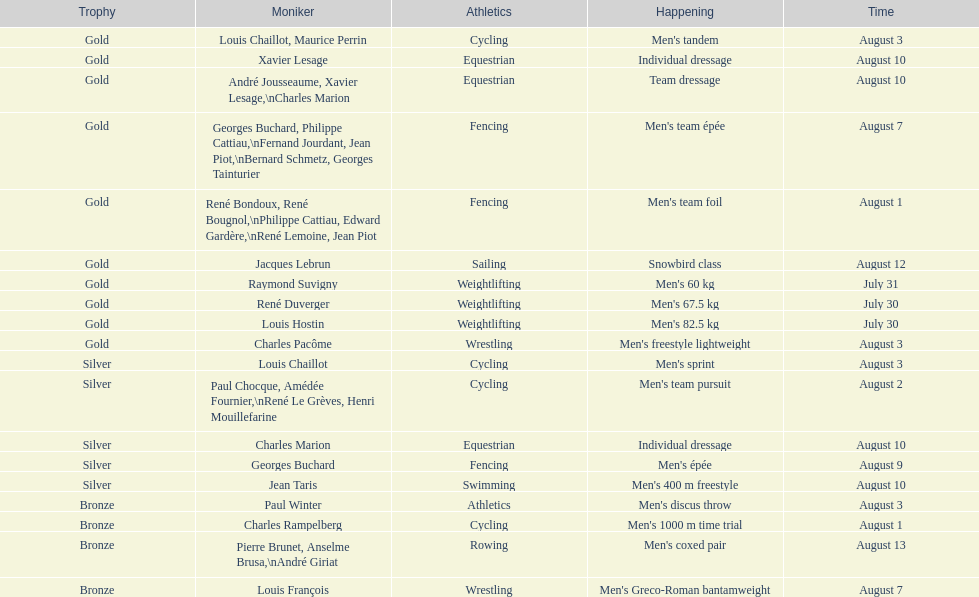I'm looking to parse the entire table for insights. Could you assist me with that? {'header': ['Trophy', 'Moniker', 'Athletics', 'Happening', 'Time'], 'rows': [['Gold', 'Louis Chaillot, Maurice Perrin', 'Cycling', "Men's tandem", 'August 3'], ['Gold', 'Xavier Lesage', 'Equestrian', 'Individual dressage', 'August 10'], ['Gold', 'André Jousseaume, Xavier Lesage,\\nCharles Marion', 'Equestrian', 'Team dressage', 'August 10'], ['Gold', 'Georges Buchard, Philippe Cattiau,\\nFernand Jourdant, Jean Piot,\\nBernard Schmetz, Georges Tainturier', 'Fencing', "Men's team épée", 'August 7'], ['Gold', 'René Bondoux, René Bougnol,\\nPhilippe Cattiau, Edward Gardère,\\nRené Lemoine, Jean Piot', 'Fencing', "Men's team foil", 'August 1'], ['Gold', 'Jacques Lebrun', 'Sailing', 'Snowbird class', 'August 12'], ['Gold', 'Raymond Suvigny', 'Weightlifting', "Men's 60 kg", 'July 31'], ['Gold', 'René Duverger', 'Weightlifting', "Men's 67.5 kg", 'July 30'], ['Gold', 'Louis Hostin', 'Weightlifting', "Men's 82.5 kg", 'July 30'], ['Gold', 'Charles Pacôme', 'Wrestling', "Men's freestyle lightweight", 'August 3'], ['Silver', 'Louis Chaillot', 'Cycling', "Men's sprint", 'August 3'], ['Silver', 'Paul Chocque, Amédée Fournier,\\nRené Le Grèves, Henri Mouillefarine', 'Cycling', "Men's team pursuit", 'August 2'], ['Silver', 'Charles Marion', 'Equestrian', 'Individual dressage', 'August 10'], ['Silver', 'Georges Buchard', 'Fencing', "Men's épée", 'August 9'], ['Silver', 'Jean Taris', 'Swimming', "Men's 400 m freestyle", 'August 10'], ['Bronze', 'Paul Winter', 'Athletics', "Men's discus throw", 'August 3'], ['Bronze', 'Charles Rampelberg', 'Cycling', "Men's 1000 m time trial", 'August 1'], ['Bronze', 'Pierre Brunet, Anselme Brusa,\\nAndré Giriat', 'Rowing', "Men's coxed pair", 'August 13'], ['Bronze', 'Louis François', 'Wrestling', "Men's Greco-Roman bantamweight", 'August 7']]} Was there more gold medals won than silver? Yes. 